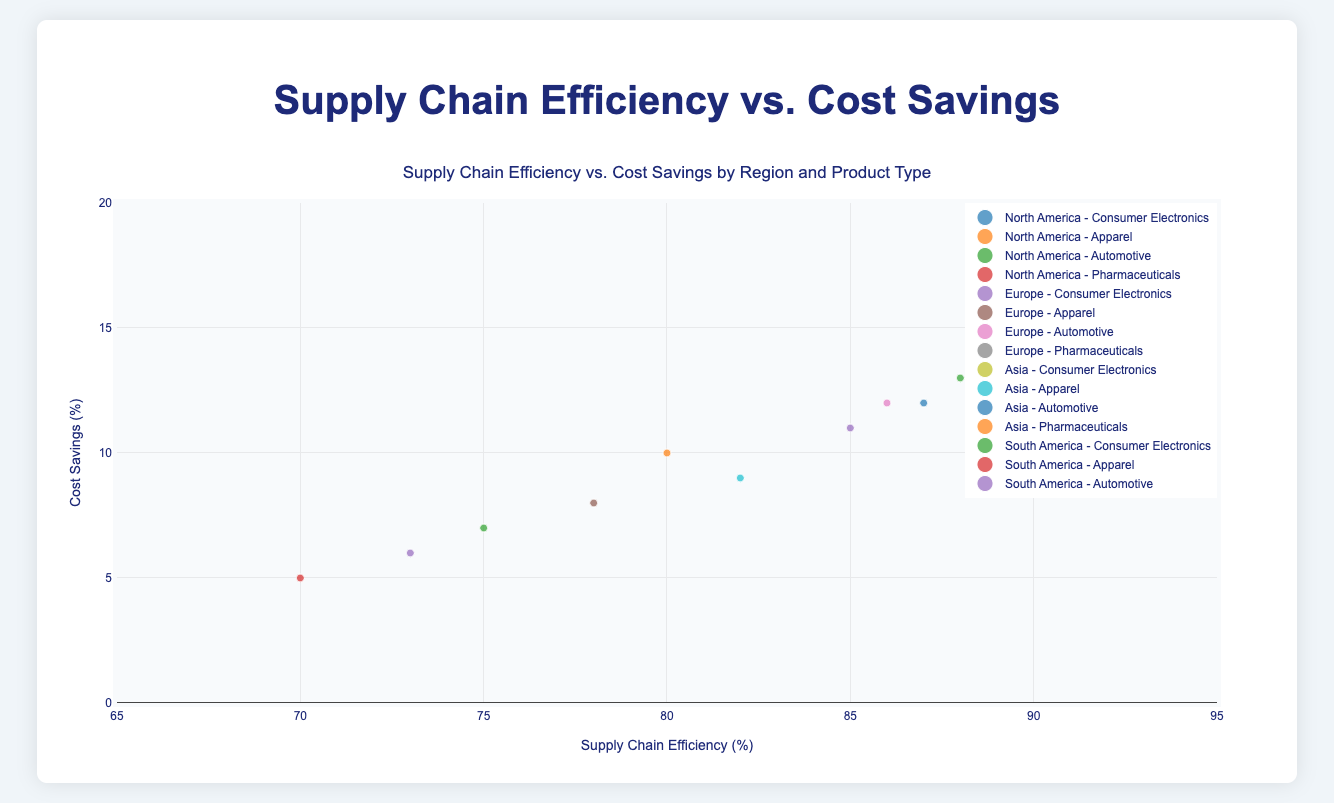What is the title of the figure? The title is usually found at the top of the figure, and it describes what the chart illustrates.
Answer: Supply Chain Efficiency vs. Cost Savings by Region and Product Type Which region has the highest cost savings for Consumer Electronics? Locate the bubbles representing Consumer Electronics in each region and identify the one with the highest y-axis value for cost savings.
Answer: Asia Compare the supply chain efficiency of Apparel products in North America and Europe. Which region is more efficient? Find the Apparel product bubbles for North America and Europe and compare their x-axis positions for supply chain efficiency.
Answer: North America What is the total volume of products in the Asia region? Sum the volumes of all products in the Asia region: 6000 (Consumer Electronics) + 4000 (Apparel) + 6200 (Automotive) + 5800 (Pharmaceuticals).
Answer: 22000 Among all regions, which region shows the lowest efficiency for Automotive products? Locate the Automotive product bubbles in each region and identify the one with the lowest x-axis value for efficiency.
Answer: South America Which product type in Europe has the highest cost savings? Find all product type bubbles in Europe and identify the one with the highest y-axis value for cost savings.
Answer: Pharmaceuticals Is there any region where Consumer Electronics and Pharmaceuticals show approximately equal efficiency? Compare the x-axis positions of Consumer Electronics and Pharmaceuticals bubbles within each region to check for similar efficiency values.
Answer: Europe (Consumer Electronics: 85, Pharmaceuticals: 90) How do the cost savings of Pharmaceuticals in North America compare to those in Europe? Compare the y-axis values of Pharmaceuticals bubbles in North America and Europe for cost savings.
Answer: North America is lower (13% vs. 14%) Which product type has the largest bubble size in the figure? Bubble size is proportional to product volume; find the product type with the largest bubble.
Answer: Automotive (Asia) 